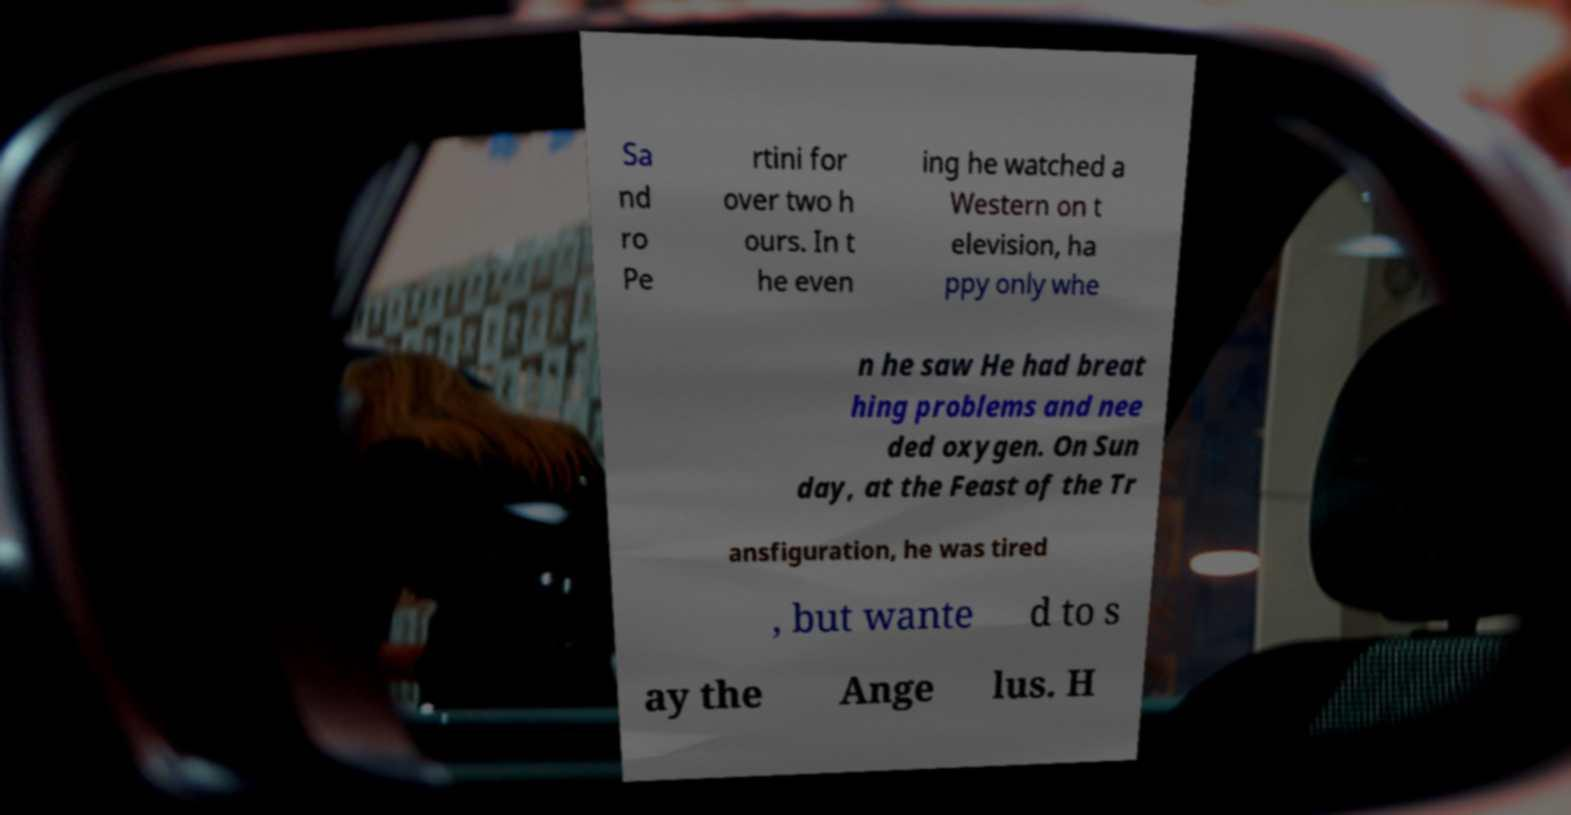Please read and relay the text visible in this image. What does it say? Sa nd ro Pe rtini for over two h ours. In t he even ing he watched a Western on t elevision, ha ppy only whe n he saw He had breat hing problems and nee ded oxygen. On Sun day, at the Feast of the Tr ansfiguration, he was tired , but wante d to s ay the Ange lus. H 